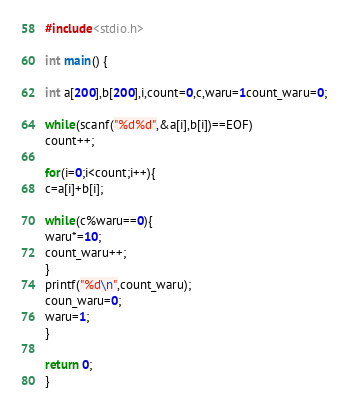Convert code to text. <code><loc_0><loc_0><loc_500><loc_500><_C_>#include<stdio.h>

int main() {

int a[200],b[200],i,count=0,c,waru=1count_waru=0;

while(scanf("%d%d",&a[i],b[i])==EOF)
count++;

for(i=0;i<count;i++){
c=a[i]+b[i];

while(c%waru==0){
waru*=10;
count_waru++;
}
printf("%d\n",count_waru);
coun_waru=0;
waru=1;
}

return 0;
}</code> 